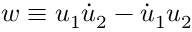<formula> <loc_0><loc_0><loc_500><loc_500>w \equiv u _ { 1 } \dot { u } _ { 2 } - \dot { u } _ { 1 } u _ { 2 }</formula> 